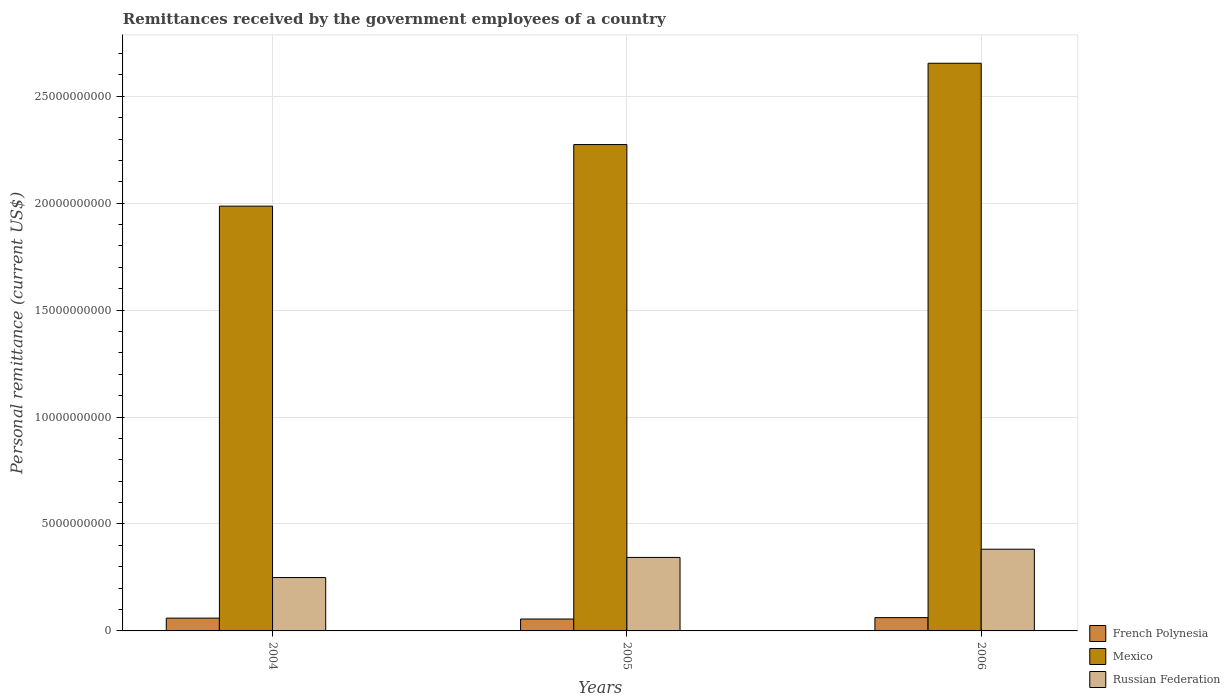How many groups of bars are there?
Keep it short and to the point. 3. Are the number of bars per tick equal to the number of legend labels?
Offer a terse response. Yes. Are the number of bars on each tick of the X-axis equal?
Make the answer very short. Yes. What is the remittances received by the government employees in Russian Federation in 2005?
Your answer should be very brief. 3.44e+09. Across all years, what is the maximum remittances received by the government employees in Russian Federation?
Your response must be concise. 3.82e+09. Across all years, what is the minimum remittances received by the government employees in French Polynesia?
Provide a succinct answer. 5.57e+08. In which year was the remittances received by the government employees in Russian Federation maximum?
Keep it short and to the point. 2006. In which year was the remittances received by the government employees in Russian Federation minimum?
Offer a very short reply. 2004. What is the total remittances received by the government employees in Mexico in the graph?
Give a very brief answer. 6.91e+1. What is the difference between the remittances received by the government employees in Russian Federation in 2004 and that in 2005?
Your response must be concise. -9.41e+08. What is the difference between the remittances received by the government employees in Mexico in 2005 and the remittances received by the government employees in French Polynesia in 2006?
Give a very brief answer. 2.21e+1. What is the average remittances received by the government employees in French Polynesia per year?
Offer a very short reply. 5.92e+08. In the year 2005, what is the difference between the remittances received by the government employees in Mexico and remittances received by the government employees in Russian Federation?
Provide a succinct answer. 1.93e+1. What is the ratio of the remittances received by the government employees in French Polynesia in 2004 to that in 2006?
Ensure brevity in your answer.  0.96. Is the remittances received by the government employees in French Polynesia in 2004 less than that in 2006?
Provide a succinct answer. Yes. Is the difference between the remittances received by the government employees in Mexico in 2004 and 2006 greater than the difference between the remittances received by the government employees in Russian Federation in 2004 and 2006?
Provide a succinct answer. No. What is the difference between the highest and the second highest remittances received by the government employees in Mexico?
Give a very brief answer. 3.80e+09. What is the difference between the highest and the lowest remittances received by the government employees in French Polynesia?
Keep it short and to the point. 6.46e+07. In how many years, is the remittances received by the government employees in Russian Federation greater than the average remittances received by the government employees in Russian Federation taken over all years?
Provide a short and direct response. 2. What does the 3rd bar from the left in 2006 represents?
Offer a terse response. Russian Federation. What does the 1st bar from the right in 2004 represents?
Provide a succinct answer. Russian Federation. Where does the legend appear in the graph?
Make the answer very short. Bottom right. What is the title of the graph?
Ensure brevity in your answer.  Remittances received by the government employees of a country. Does "Turks and Caicos Islands" appear as one of the legend labels in the graph?
Provide a short and direct response. No. What is the label or title of the Y-axis?
Provide a succinct answer. Personal remittance (current US$). What is the Personal remittance (current US$) of French Polynesia in 2004?
Your answer should be very brief. 5.98e+08. What is the Personal remittance (current US$) of Mexico in 2004?
Your response must be concise. 1.99e+1. What is the Personal remittance (current US$) of Russian Federation in 2004?
Provide a short and direct response. 2.50e+09. What is the Personal remittance (current US$) of French Polynesia in 2005?
Your answer should be very brief. 5.57e+08. What is the Personal remittance (current US$) of Mexico in 2005?
Keep it short and to the point. 2.27e+1. What is the Personal remittance (current US$) of Russian Federation in 2005?
Give a very brief answer. 3.44e+09. What is the Personal remittance (current US$) in French Polynesia in 2006?
Your response must be concise. 6.22e+08. What is the Personal remittance (current US$) in Mexico in 2006?
Give a very brief answer. 2.65e+1. What is the Personal remittance (current US$) in Russian Federation in 2006?
Provide a succinct answer. 3.82e+09. Across all years, what is the maximum Personal remittance (current US$) in French Polynesia?
Ensure brevity in your answer.  6.22e+08. Across all years, what is the maximum Personal remittance (current US$) in Mexico?
Your answer should be compact. 2.65e+1. Across all years, what is the maximum Personal remittance (current US$) of Russian Federation?
Offer a very short reply. 3.82e+09. Across all years, what is the minimum Personal remittance (current US$) of French Polynesia?
Give a very brief answer. 5.57e+08. Across all years, what is the minimum Personal remittance (current US$) of Mexico?
Give a very brief answer. 1.99e+1. Across all years, what is the minimum Personal remittance (current US$) in Russian Federation?
Give a very brief answer. 2.50e+09. What is the total Personal remittance (current US$) of French Polynesia in the graph?
Give a very brief answer. 1.78e+09. What is the total Personal remittance (current US$) in Mexico in the graph?
Give a very brief answer. 6.91e+1. What is the total Personal remittance (current US$) of Russian Federation in the graph?
Ensure brevity in your answer.  9.75e+09. What is the difference between the Personal remittance (current US$) in French Polynesia in 2004 and that in 2005?
Keep it short and to the point. 4.11e+07. What is the difference between the Personal remittance (current US$) of Mexico in 2004 and that in 2005?
Your response must be concise. -2.88e+09. What is the difference between the Personal remittance (current US$) in Russian Federation in 2004 and that in 2005?
Your response must be concise. -9.41e+08. What is the difference between the Personal remittance (current US$) in French Polynesia in 2004 and that in 2006?
Keep it short and to the point. -2.35e+07. What is the difference between the Personal remittance (current US$) of Mexico in 2004 and that in 2006?
Offer a terse response. -6.68e+09. What is the difference between the Personal remittance (current US$) in Russian Federation in 2004 and that in 2006?
Make the answer very short. -1.33e+09. What is the difference between the Personal remittance (current US$) in French Polynesia in 2005 and that in 2006?
Your answer should be very brief. -6.46e+07. What is the difference between the Personal remittance (current US$) in Mexico in 2005 and that in 2006?
Offer a terse response. -3.80e+09. What is the difference between the Personal remittance (current US$) of Russian Federation in 2005 and that in 2006?
Your answer should be very brief. -3.84e+08. What is the difference between the Personal remittance (current US$) of French Polynesia in 2004 and the Personal remittance (current US$) of Mexico in 2005?
Your answer should be compact. -2.21e+1. What is the difference between the Personal remittance (current US$) in French Polynesia in 2004 and the Personal remittance (current US$) in Russian Federation in 2005?
Offer a very short reply. -2.84e+09. What is the difference between the Personal remittance (current US$) of Mexico in 2004 and the Personal remittance (current US$) of Russian Federation in 2005?
Give a very brief answer. 1.64e+1. What is the difference between the Personal remittance (current US$) in French Polynesia in 2004 and the Personal remittance (current US$) in Mexico in 2006?
Offer a very short reply. -2.59e+1. What is the difference between the Personal remittance (current US$) in French Polynesia in 2004 and the Personal remittance (current US$) in Russian Federation in 2006?
Keep it short and to the point. -3.22e+09. What is the difference between the Personal remittance (current US$) in Mexico in 2004 and the Personal remittance (current US$) in Russian Federation in 2006?
Offer a very short reply. 1.60e+1. What is the difference between the Personal remittance (current US$) in French Polynesia in 2005 and the Personal remittance (current US$) in Mexico in 2006?
Keep it short and to the point. -2.60e+1. What is the difference between the Personal remittance (current US$) of French Polynesia in 2005 and the Personal remittance (current US$) of Russian Federation in 2006?
Your response must be concise. -3.26e+09. What is the difference between the Personal remittance (current US$) of Mexico in 2005 and the Personal remittance (current US$) of Russian Federation in 2006?
Provide a short and direct response. 1.89e+1. What is the average Personal remittance (current US$) of French Polynesia per year?
Keep it short and to the point. 5.92e+08. What is the average Personal remittance (current US$) in Mexico per year?
Your answer should be very brief. 2.30e+1. What is the average Personal remittance (current US$) in Russian Federation per year?
Give a very brief answer. 3.25e+09. In the year 2004, what is the difference between the Personal remittance (current US$) in French Polynesia and Personal remittance (current US$) in Mexico?
Offer a very short reply. -1.93e+1. In the year 2004, what is the difference between the Personal remittance (current US$) of French Polynesia and Personal remittance (current US$) of Russian Federation?
Your answer should be very brief. -1.90e+09. In the year 2004, what is the difference between the Personal remittance (current US$) in Mexico and Personal remittance (current US$) in Russian Federation?
Your answer should be very brief. 1.74e+1. In the year 2005, what is the difference between the Personal remittance (current US$) in French Polynesia and Personal remittance (current US$) in Mexico?
Make the answer very short. -2.22e+1. In the year 2005, what is the difference between the Personal remittance (current US$) of French Polynesia and Personal remittance (current US$) of Russian Federation?
Make the answer very short. -2.88e+09. In the year 2005, what is the difference between the Personal remittance (current US$) in Mexico and Personal remittance (current US$) in Russian Federation?
Your answer should be compact. 1.93e+1. In the year 2006, what is the difference between the Personal remittance (current US$) in French Polynesia and Personal remittance (current US$) in Mexico?
Provide a short and direct response. -2.59e+1. In the year 2006, what is the difference between the Personal remittance (current US$) in French Polynesia and Personal remittance (current US$) in Russian Federation?
Keep it short and to the point. -3.20e+09. In the year 2006, what is the difference between the Personal remittance (current US$) in Mexico and Personal remittance (current US$) in Russian Federation?
Make the answer very short. 2.27e+1. What is the ratio of the Personal remittance (current US$) in French Polynesia in 2004 to that in 2005?
Ensure brevity in your answer.  1.07. What is the ratio of the Personal remittance (current US$) of Mexico in 2004 to that in 2005?
Make the answer very short. 0.87. What is the ratio of the Personal remittance (current US$) of Russian Federation in 2004 to that in 2005?
Your response must be concise. 0.73. What is the ratio of the Personal remittance (current US$) in French Polynesia in 2004 to that in 2006?
Your response must be concise. 0.96. What is the ratio of the Personal remittance (current US$) of Mexico in 2004 to that in 2006?
Your answer should be very brief. 0.75. What is the ratio of the Personal remittance (current US$) in Russian Federation in 2004 to that in 2006?
Offer a very short reply. 0.65. What is the ratio of the Personal remittance (current US$) of French Polynesia in 2005 to that in 2006?
Your response must be concise. 0.9. What is the ratio of the Personal remittance (current US$) of Mexico in 2005 to that in 2006?
Your answer should be very brief. 0.86. What is the ratio of the Personal remittance (current US$) in Russian Federation in 2005 to that in 2006?
Offer a very short reply. 0.9. What is the difference between the highest and the second highest Personal remittance (current US$) of French Polynesia?
Make the answer very short. 2.35e+07. What is the difference between the highest and the second highest Personal remittance (current US$) in Mexico?
Make the answer very short. 3.80e+09. What is the difference between the highest and the second highest Personal remittance (current US$) in Russian Federation?
Offer a very short reply. 3.84e+08. What is the difference between the highest and the lowest Personal remittance (current US$) of French Polynesia?
Your answer should be very brief. 6.46e+07. What is the difference between the highest and the lowest Personal remittance (current US$) in Mexico?
Ensure brevity in your answer.  6.68e+09. What is the difference between the highest and the lowest Personal remittance (current US$) in Russian Federation?
Provide a succinct answer. 1.33e+09. 